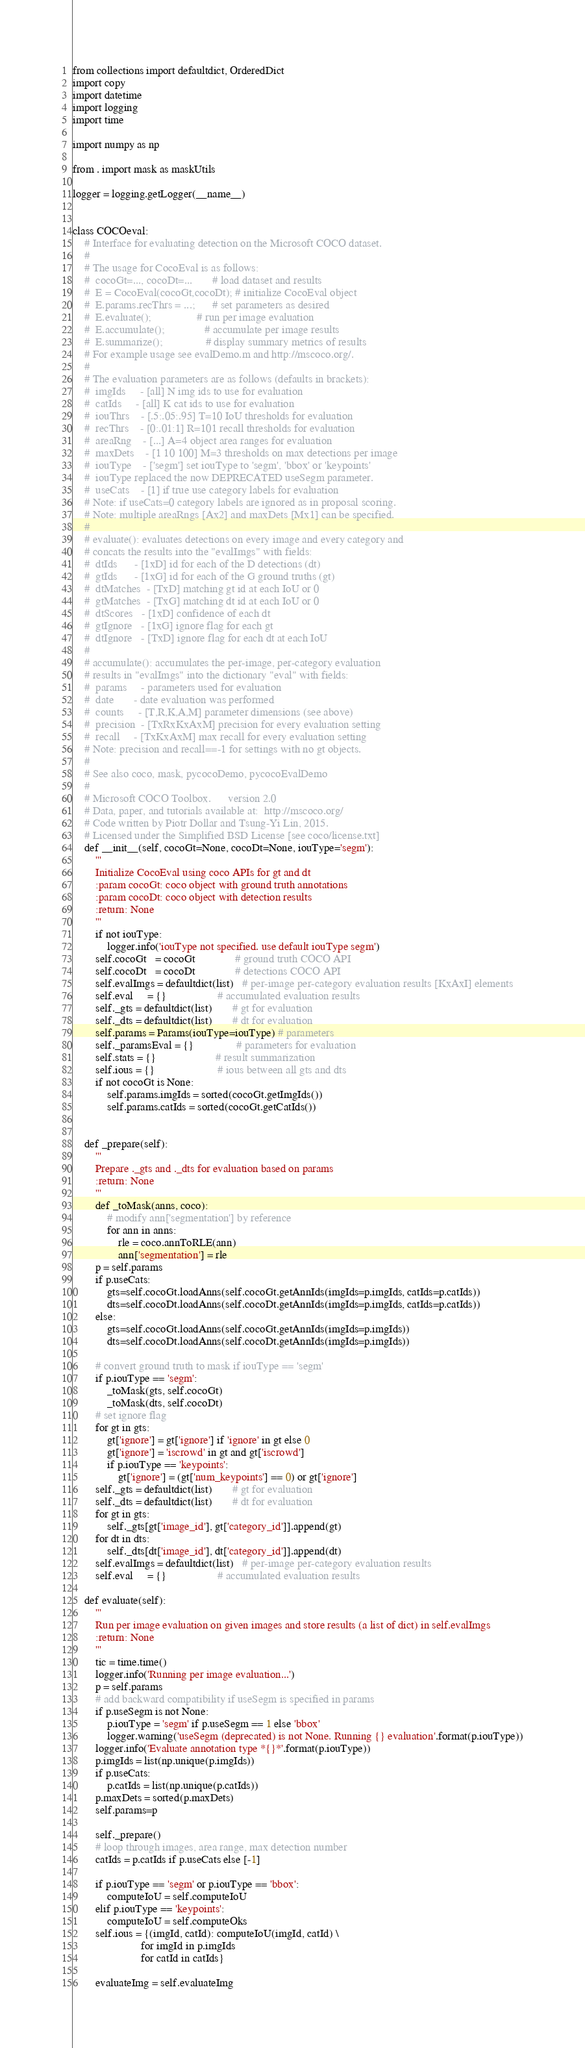Convert code to text. <code><loc_0><loc_0><loc_500><loc_500><_Python_>from collections import defaultdict, OrderedDict
import copy
import datetime
import logging
import time

import numpy as np

from . import mask as maskUtils

logger = logging.getLogger(__name__)


class COCOeval:
    # Interface for evaluating detection on the Microsoft COCO dataset.
    #
    # The usage for CocoEval is as follows:
    #  cocoGt=..., cocoDt=...       # load dataset and results
    #  E = CocoEval(cocoGt,cocoDt); # initialize CocoEval object
    #  E.params.recThrs = ...;      # set parameters as desired
    #  E.evaluate();                # run per image evaluation
    #  E.accumulate();              # accumulate per image results
    #  E.summarize();               # display summary metrics of results
    # For example usage see evalDemo.m and http://mscoco.org/.
    #
    # The evaluation parameters are as follows (defaults in brackets):
    #  imgIds     - [all] N img ids to use for evaluation
    #  catIds     - [all] K cat ids to use for evaluation
    #  iouThrs    - [.5:.05:.95] T=10 IoU thresholds for evaluation
    #  recThrs    - [0:.01:1] R=101 recall thresholds for evaluation
    #  areaRng    - [...] A=4 object area ranges for evaluation
    #  maxDets    - [1 10 100] M=3 thresholds on max detections per image
    #  iouType    - ['segm'] set iouType to 'segm', 'bbox' or 'keypoints'
    #  iouType replaced the now DEPRECATED useSegm parameter.
    #  useCats    - [1] if true use category labels for evaluation
    # Note: if useCats=0 category labels are ignored as in proposal scoring.
    # Note: multiple areaRngs [Ax2] and maxDets [Mx1] can be specified.
    #
    # evaluate(): evaluates detections on every image and every category and
    # concats the results into the "evalImgs" with fields:
    #  dtIds      - [1xD] id for each of the D detections (dt)
    #  gtIds      - [1xG] id for each of the G ground truths (gt)
    #  dtMatches  - [TxD] matching gt id at each IoU or 0
    #  gtMatches  - [TxG] matching dt id at each IoU or 0
    #  dtScores   - [1xD] confidence of each dt
    #  gtIgnore   - [1xG] ignore flag for each gt
    #  dtIgnore   - [TxD] ignore flag for each dt at each IoU
    #
    # accumulate(): accumulates the per-image, per-category evaluation
    # results in "evalImgs" into the dictionary "eval" with fields:
    #  params     - parameters used for evaluation
    #  date       - date evaluation was performed
    #  counts     - [T,R,K,A,M] parameter dimensions (see above)
    #  precision  - [TxRxKxAxM] precision for every evaluation setting
    #  recall     - [TxKxAxM] max recall for every evaluation setting
    # Note: precision and recall==-1 for settings with no gt objects.
    #
    # See also coco, mask, pycocoDemo, pycocoEvalDemo
    #
    # Microsoft COCO Toolbox.      version 2.0
    # Data, paper, and tutorials available at:  http://mscoco.org/
    # Code written by Piotr Dollar and Tsung-Yi Lin, 2015.
    # Licensed under the Simplified BSD License [see coco/license.txt]
    def __init__(self, cocoGt=None, cocoDt=None, iouType='segm'):
        '''
        Initialize CocoEval using coco APIs for gt and dt
        :param cocoGt: coco object with ground truth annotations
        :param cocoDt: coco object with detection results
        :return: None
        '''
        if not iouType:
            logger.info('iouType not specified. use default iouType segm')
        self.cocoGt   = cocoGt              # ground truth COCO API
        self.cocoDt   = cocoDt              # detections COCO API
        self.evalImgs = defaultdict(list)   # per-image per-category evaluation results [KxAxI] elements
        self.eval     = {}                  # accumulated evaluation results
        self._gts = defaultdict(list)       # gt for evaluation
        self._dts = defaultdict(list)       # dt for evaluation
        self.params = Params(iouType=iouType) # parameters
        self._paramsEval = {}               # parameters for evaluation
        self.stats = {}                     # result summarization
        self.ious = {}                      # ious between all gts and dts
        if not cocoGt is None:
            self.params.imgIds = sorted(cocoGt.getImgIds())
            self.params.catIds = sorted(cocoGt.getCatIds())


    def _prepare(self):
        '''
        Prepare ._gts and ._dts for evaluation based on params
        :return: None
        '''
        def _toMask(anns, coco):
            # modify ann['segmentation'] by reference
            for ann in anns:
                rle = coco.annToRLE(ann)
                ann['segmentation'] = rle
        p = self.params
        if p.useCats:
            gts=self.cocoGt.loadAnns(self.cocoGt.getAnnIds(imgIds=p.imgIds, catIds=p.catIds))
            dts=self.cocoDt.loadAnns(self.cocoDt.getAnnIds(imgIds=p.imgIds, catIds=p.catIds))
        else:
            gts=self.cocoGt.loadAnns(self.cocoGt.getAnnIds(imgIds=p.imgIds))
            dts=self.cocoDt.loadAnns(self.cocoDt.getAnnIds(imgIds=p.imgIds))

        # convert ground truth to mask if iouType == 'segm'
        if p.iouType == 'segm':
            _toMask(gts, self.cocoGt)
            _toMask(dts, self.cocoDt)
        # set ignore flag
        for gt in gts:
            gt['ignore'] = gt['ignore'] if 'ignore' in gt else 0
            gt['ignore'] = 'iscrowd' in gt and gt['iscrowd']
            if p.iouType == 'keypoints':
                gt['ignore'] = (gt['num_keypoints'] == 0) or gt['ignore']
        self._gts = defaultdict(list)       # gt for evaluation
        self._dts = defaultdict(list)       # dt for evaluation
        for gt in gts:
            self._gts[gt['image_id'], gt['category_id']].append(gt)
        for dt in dts:
            self._dts[dt['image_id'], dt['category_id']].append(dt)
        self.evalImgs = defaultdict(list)   # per-image per-category evaluation results
        self.eval     = {}                  # accumulated evaluation results

    def evaluate(self):
        '''
        Run per image evaluation on given images and store results (a list of dict) in self.evalImgs
        :return: None
        '''
        tic = time.time()
        logger.info('Running per image evaluation...')
        p = self.params
        # add backward compatibility if useSegm is specified in params
        if p.useSegm is not None:
            p.iouType = 'segm' if p.useSegm == 1 else 'bbox'
            logger.warning('useSegm (deprecated) is not None. Running {} evaluation'.format(p.iouType))
        logger.info('Evaluate annotation type *{}*'.format(p.iouType))
        p.imgIds = list(np.unique(p.imgIds))
        if p.useCats:
            p.catIds = list(np.unique(p.catIds))
        p.maxDets = sorted(p.maxDets)
        self.params=p

        self._prepare()
        # loop through images, area range, max detection number
        catIds = p.catIds if p.useCats else [-1]

        if p.iouType == 'segm' or p.iouType == 'bbox':
            computeIoU = self.computeIoU
        elif p.iouType == 'keypoints':
            computeIoU = self.computeOks
        self.ious = {(imgId, catId): computeIoU(imgId, catId) \
                        for imgId in p.imgIds
                        for catId in catIds}

        evaluateImg = self.evaluateImg</code> 